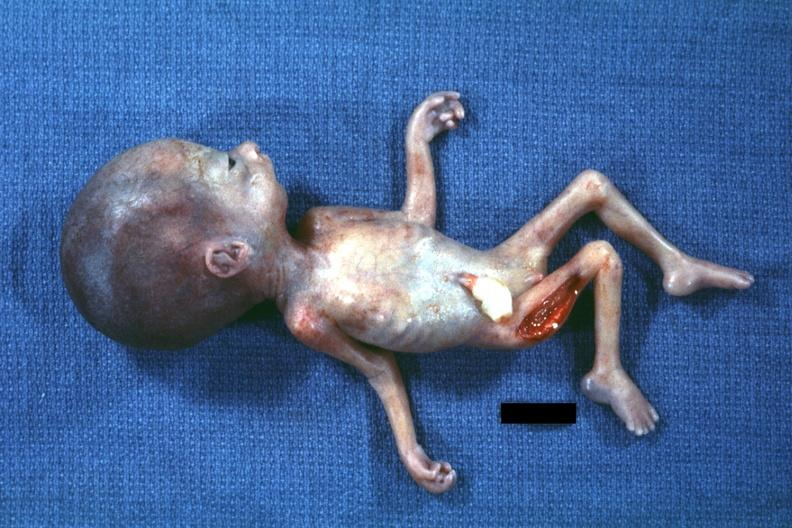what is present?
Answer the question using a single word or phrase. Micrognathia triploid fetus 